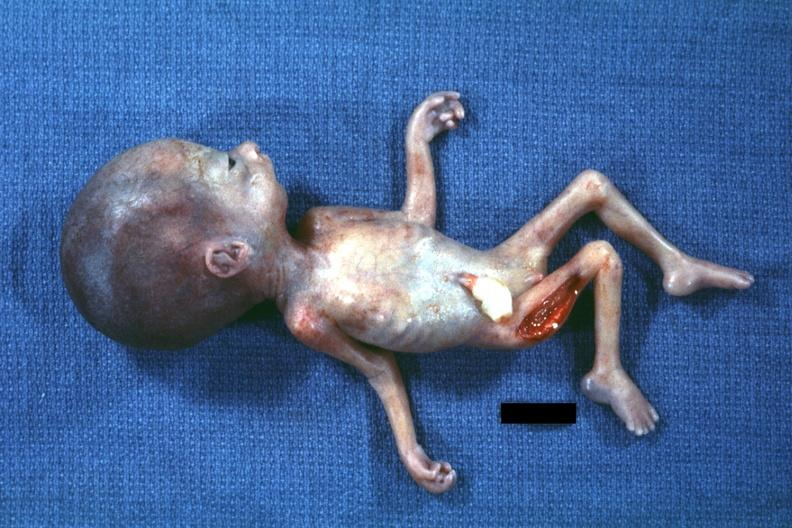what is present?
Answer the question using a single word or phrase. Micrognathia triploid fetus 